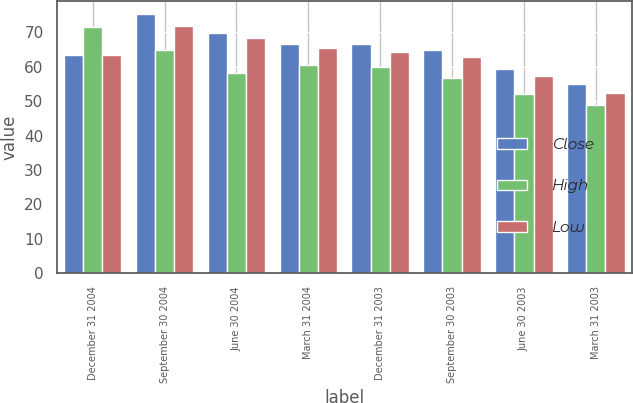<chart> <loc_0><loc_0><loc_500><loc_500><stacked_bar_chart><ecel><fcel>December 31 2004<fcel>September 30 2004<fcel>June 30 2004<fcel>March 31 2004<fcel>December 31 2003<fcel>September 30 2003<fcel>June 30 2003<fcel>March 31 2003<nl><fcel>Close<fcel>63.465<fcel>75.31<fcel>69.73<fcel>66.64<fcel>66.6<fcel>64.98<fcel>59.4<fcel>54.91<nl><fcel>High<fcel>71.65<fcel>64.89<fcel>58.15<fcel>60.65<fcel>59.88<fcel>56.67<fcel>52.2<fcel>49<nl><fcel>Low<fcel>63.465<fcel>71.85<fcel>68.35<fcel>65.5<fcel>64.22<fcel>62.71<fcel>57.25<fcel>52.25<nl></chart> 